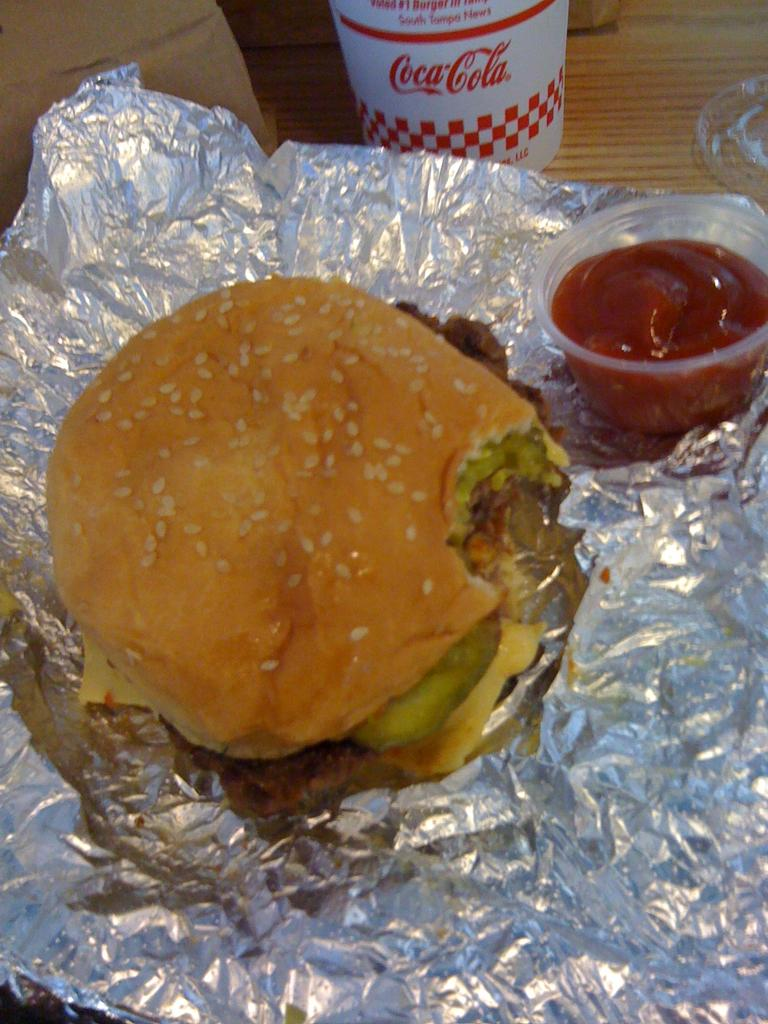What type of food is visible on the foil in the image? There is a burger on the foil in the image. What accompanies the burger in the image? There is a sauce beside the burger. What is the container for the liquid in the image? There is a cup in the image. What other objects can be seen on the table in the image? There are a few other objects on the table in the image. What class is the sister attending in the image? There is no class or sister present in the image; it features a burger, sauce, cup, and other objects on a table. 